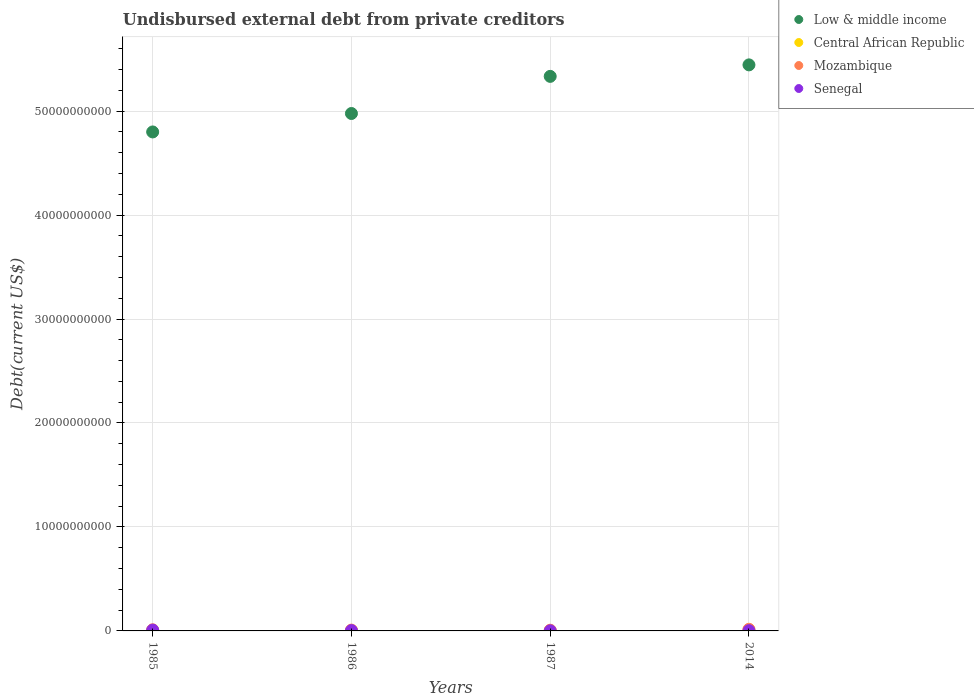What is the total debt in Central African Republic in 1985?
Your response must be concise. 2.37e+06. Across all years, what is the maximum total debt in Mozambique?
Offer a very short reply. 1.57e+08. Across all years, what is the minimum total debt in Senegal?
Offer a terse response. 1.13e+07. In which year was the total debt in Low & middle income maximum?
Offer a very short reply. 2014. What is the total total debt in Senegal in the graph?
Offer a very short reply. 1.46e+08. What is the difference between the total debt in Low & middle income in 1985 and that in 1986?
Offer a very short reply. -1.77e+09. What is the difference between the total debt in Senegal in 1986 and the total debt in Mozambique in 1987?
Give a very brief answer. -3.46e+07. What is the average total debt in Mozambique per year?
Your response must be concise. 1.04e+08. In the year 1987, what is the difference between the total debt in Low & middle income and total debt in Central African Republic?
Your answer should be compact. 5.33e+1. What is the ratio of the total debt in Central African Republic in 1986 to that in 2014?
Your response must be concise. 0.1. Is the difference between the total debt in Low & middle income in 1986 and 1987 greater than the difference between the total debt in Central African Republic in 1986 and 1987?
Your response must be concise. No. What is the difference between the highest and the second highest total debt in Central African Republic?
Provide a succinct answer. 1.76e+07. What is the difference between the highest and the lowest total debt in Mozambique?
Your answer should be very brief. 8.82e+07. In how many years, is the total debt in Low & middle income greater than the average total debt in Low & middle income taken over all years?
Ensure brevity in your answer.  2. Is the sum of the total debt in Low & middle income in 1985 and 1986 greater than the maximum total debt in Mozambique across all years?
Your answer should be compact. Yes. Is it the case that in every year, the sum of the total debt in Low & middle income and total debt in Senegal  is greater than the sum of total debt in Central African Republic and total debt in Mozambique?
Give a very brief answer. Yes. Does the total debt in Central African Republic monotonically increase over the years?
Your response must be concise. No. Is the total debt in Senegal strictly less than the total debt in Low & middle income over the years?
Make the answer very short. Yes. What is the difference between two consecutive major ticks on the Y-axis?
Offer a very short reply. 1.00e+1. Are the values on the major ticks of Y-axis written in scientific E-notation?
Your answer should be compact. No. Does the graph contain grids?
Provide a succinct answer. Yes. What is the title of the graph?
Offer a terse response. Undisbursed external debt from private creditors. What is the label or title of the X-axis?
Offer a terse response. Years. What is the label or title of the Y-axis?
Provide a short and direct response. Debt(current US$). What is the Debt(current US$) in Low & middle income in 1985?
Make the answer very short. 4.80e+1. What is the Debt(current US$) in Central African Republic in 1985?
Offer a very short reply. 2.37e+06. What is the Debt(current US$) in Mozambique in 1985?
Make the answer very short. 1.10e+08. What is the Debt(current US$) in Senegal in 1985?
Give a very brief answer. 7.67e+07. What is the Debt(current US$) of Low & middle income in 1986?
Your response must be concise. 4.98e+1. What is the Debt(current US$) in Central African Republic in 1986?
Keep it short and to the point. 1.96e+06. What is the Debt(current US$) in Mozambique in 1986?
Provide a succinct answer. 7.97e+07. What is the Debt(current US$) of Senegal in 1986?
Offer a very short reply. 3.37e+07. What is the Debt(current US$) in Low & middle income in 1987?
Your answer should be very brief. 5.33e+1. What is the Debt(current US$) of Central African Republic in 1987?
Your response must be concise. 1.33e+06. What is the Debt(current US$) of Mozambique in 1987?
Your answer should be very brief. 6.83e+07. What is the Debt(current US$) in Senegal in 1987?
Provide a short and direct response. 1.13e+07. What is the Debt(current US$) of Low & middle income in 2014?
Offer a terse response. 5.44e+1. What is the Debt(current US$) of Central African Republic in 2014?
Offer a terse response. 2.00e+07. What is the Debt(current US$) of Mozambique in 2014?
Keep it short and to the point. 1.57e+08. What is the Debt(current US$) in Senegal in 2014?
Offer a very short reply. 2.39e+07. Across all years, what is the maximum Debt(current US$) in Low & middle income?
Provide a succinct answer. 5.44e+1. Across all years, what is the maximum Debt(current US$) in Central African Republic?
Offer a terse response. 2.00e+07. Across all years, what is the maximum Debt(current US$) of Mozambique?
Give a very brief answer. 1.57e+08. Across all years, what is the maximum Debt(current US$) of Senegal?
Your answer should be compact. 7.67e+07. Across all years, what is the minimum Debt(current US$) of Low & middle income?
Give a very brief answer. 4.80e+1. Across all years, what is the minimum Debt(current US$) of Central African Republic?
Give a very brief answer. 1.33e+06. Across all years, what is the minimum Debt(current US$) of Mozambique?
Keep it short and to the point. 6.83e+07. Across all years, what is the minimum Debt(current US$) of Senegal?
Provide a succinct answer. 1.13e+07. What is the total Debt(current US$) of Low & middle income in the graph?
Provide a short and direct response. 2.06e+11. What is the total Debt(current US$) in Central African Republic in the graph?
Keep it short and to the point. 2.57e+07. What is the total Debt(current US$) in Mozambique in the graph?
Keep it short and to the point. 4.15e+08. What is the total Debt(current US$) of Senegal in the graph?
Your response must be concise. 1.46e+08. What is the difference between the Debt(current US$) in Low & middle income in 1985 and that in 1986?
Provide a short and direct response. -1.77e+09. What is the difference between the Debt(current US$) of Central African Republic in 1985 and that in 1986?
Offer a terse response. 4.17e+05. What is the difference between the Debt(current US$) in Mozambique in 1985 and that in 1986?
Provide a short and direct response. 3.05e+07. What is the difference between the Debt(current US$) in Senegal in 1985 and that in 1986?
Provide a short and direct response. 4.30e+07. What is the difference between the Debt(current US$) in Low & middle income in 1985 and that in 1987?
Offer a very short reply. -5.35e+09. What is the difference between the Debt(current US$) of Central African Republic in 1985 and that in 1987?
Your response must be concise. 1.04e+06. What is the difference between the Debt(current US$) in Mozambique in 1985 and that in 1987?
Provide a succinct answer. 4.18e+07. What is the difference between the Debt(current US$) of Senegal in 1985 and that in 1987?
Give a very brief answer. 6.54e+07. What is the difference between the Debt(current US$) in Low & middle income in 1985 and that in 2014?
Your answer should be compact. -6.45e+09. What is the difference between the Debt(current US$) in Central African Republic in 1985 and that in 2014?
Provide a succinct answer. -1.76e+07. What is the difference between the Debt(current US$) in Mozambique in 1985 and that in 2014?
Provide a short and direct response. -4.64e+07. What is the difference between the Debt(current US$) in Senegal in 1985 and that in 2014?
Make the answer very short. 5.28e+07. What is the difference between the Debt(current US$) in Low & middle income in 1986 and that in 1987?
Ensure brevity in your answer.  -3.57e+09. What is the difference between the Debt(current US$) of Central African Republic in 1986 and that in 1987?
Keep it short and to the point. 6.28e+05. What is the difference between the Debt(current US$) of Mozambique in 1986 and that in 1987?
Provide a succinct answer. 1.14e+07. What is the difference between the Debt(current US$) in Senegal in 1986 and that in 1987?
Offer a terse response. 2.24e+07. What is the difference between the Debt(current US$) of Low & middle income in 1986 and that in 2014?
Make the answer very short. -4.68e+09. What is the difference between the Debt(current US$) of Central African Republic in 1986 and that in 2014?
Offer a terse response. -1.80e+07. What is the difference between the Debt(current US$) in Mozambique in 1986 and that in 2014?
Your answer should be very brief. -7.69e+07. What is the difference between the Debt(current US$) of Senegal in 1986 and that in 2014?
Provide a short and direct response. 9.77e+06. What is the difference between the Debt(current US$) of Low & middle income in 1987 and that in 2014?
Provide a short and direct response. -1.11e+09. What is the difference between the Debt(current US$) in Central African Republic in 1987 and that in 2014?
Keep it short and to the point. -1.87e+07. What is the difference between the Debt(current US$) of Mozambique in 1987 and that in 2014?
Offer a very short reply. -8.82e+07. What is the difference between the Debt(current US$) of Senegal in 1987 and that in 2014?
Provide a short and direct response. -1.27e+07. What is the difference between the Debt(current US$) of Low & middle income in 1985 and the Debt(current US$) of Central African Republic in 1986?
Your response must be concise. 4.80e+1. What is the difference between the Debt(current US$) of Low & middle income in 1985 and the Debt(current US$) of Mozambique in 1986?
Your answer should be compact. 4.79e+1. What is the difference between the Debt(current US$) of Low & middle income in 1985 and the Debt(current US$) of Senegal in 1986?
Provide a succinct answer. 4.80e+1. What is the difference between the Debt(current US$) of Central African Republic in 1985 and the Debt(current US$) of Mozambique in 1986?
Offer a very short reply. -7.73e+07. What is the difference between the Debt(current US$) of Central African Republic in 1985 and the Debt(current US$) of Senegal in 1986?
Give a very brief answer. -3.13e+07. What is the difference between the Debt(current US$) in Mozambique in 1985 and the Debt(current US$) in Senegal in 1986?
Your answer should be very brief. 7.64e+07. What is the difference between the Debt(current US$) in Low & middle income in 1985 and the Debt(current US$) in Central African Republic in 1987?
Your answer should be very brief. 4.80e+1. What is the difference between the Debt(current US$) in Low & middle income in 1985 and the Debt(current US$) in Mozambique in 1987?
Your response must be concise. 4.79e+1. What is the difference between the Debt(current US$) in Low & middle income in 1985 and the Debt(current US$) in Senegal in 1987?
Offer a terse response. 4.80e+1. What is the difference between the Debt(current US$) of Central African Republic in 1985 and the Debt(current US$) of Mozambique in 1987?
Offer a very short reply. -6.59e+07. What is the difference between the Debt(current US$) of Central African Republic in 1985 and the Debt(current US$) of Senegal in 1987?
Offer a very short reply. -8.89e+06. What is the difference between the Debt(current US$) in Mozambique in 1985 and the Debt(current US$) in Senegal in 1987?
Provide a short and direct response. 9.89e+07. What is the difference between the Debt(current US$) of Low & middle income in 1985 and the Debt(current US$) of Central African Republic in 2014?
Offer a terse response. 4.80e+1. What is the difference between the Debt(current US$) of Low & middle income in 1985 and the Debt(current US$) of Mozambique in 2014?
Offer a terse response. 4.78e+1. What is the difference between the Debt(current US$) of Low & middle income in 1985 and the Debt(current US$) of Senegal in 2014?
Your answer should be very brief. 4.80e+1. What is the difference between the Debt(current US$) in Central African Republic in 1985 and the Debt(current US$) in Mozambique in 2014?
Keep it short and to the point. -1.54e+08. What is the difference between the Debt(current US$) in Central African Republic in 1985 and the Debt(current US$) in Senegal in 2014?
Your response must be concise. -2.15e+07. What is the difference between the Debt(current US$) in Mozambique in 1985 and the Debt(current US$) in Senegal in 2014?
Provide a short and direct response. 8.62e+07. What is the difference between the Debt(current US$) in Low & middle income in 1986 and the Debt(current US$) in Central African Republic in 1987?
Your answer should be very brief. 4.98e+1. What is the difference between the Debt(current US$) of Low & middle income in 1986 and the Debt(current US$) of Mozambique in 1987?
Your response must be concise. 4.97e+1. What is the difference between the Debt(current US$) of Low & middle income in 1986 and the Debt(current US$) of Senegal in 1987?
Provide a succinct answer. 4.98e+1. What is the difference between the Debt(current US$) in Central African Republic in 1986 and the Debt(current US$) in Mozambique in 1987?
Your answer should be compact. -6.63e+07. What is the difference between the Debt(current US$) in Central African Republic in 1986 and the Debt(current US$) in Senegal in 1987?
Offer a terse response. -9.31e+06. What is the difference between the Debt(current US$) in Mozambique in 1986 and the Debt(current US$) in Senegal in 1987?
Offer a very short reply. 6.84e+07. What is the difference between the Debt(current US$) of Low & middle income in 1986 and the Debt(current US$) of Central African Republic in 2014?
Your answer should be compact. 4.97e+1. What is the difference between the Debt(current US$) in Low & middle income in 1986 and the Debt(current US$) in Mozambique in 2014?
Your response must be concise. 4.96e+1. What is the difference between the Debt(current US$) in Low & middle income in 1986 and the Debt(current US$) in Senegal in 2014?
Keep it short and to the point. 4.97e+1. What is the difference between the Debt(current US$) in Central African Republic in 1986 and the Debt(current US$) in Mozambique in 2014?
Provide a short and direct response. -1.55e+08. What is the difference between the Debt(current US$) of Central African Republic in 1986 and the Debt(current US$) of Senegal in 2014?
Give a very brief answer. -2.20e+07. What is the difference between the Debt(current US$) in Mozambique in 1986 and the Debt(current US$) in Senegal in 2014?
Provide a short and direct response. 5.57e+07. What is the difference between the Debt(current US$) of Low & middle income in 1987 and the Debt(current US$) of Central African Republic in 2014?
Offer a very short reply. 5.33e+1. What is the difference between the Debt(current US$) in Low & middle income in 1987 and the Debt(current US$) in Mozambique in 2014?
Offer a terse response. 5.32e+1. What is the difference between the Debt(current US$) of Low & middle income in 1987 and the Debt(current US$) of Senegal in 2014?
Your answer should be compact. 5.33e+1. What is the difference between the Debt(current US$) in Central African Republic in 1987 and the Debt(current US$) in Mozambique in 2014?
Offer a terse response. -1.55e+08. What is the difference between the Debt(current US$) in Central African Republic in 1987 and the Debt(current US$) in Senegal in 2014?
Ensure brevity in your answer.  -2.26e+07. What is the difference between the Debt(current US$) in Mozambique in 1987 and the Debt(current US$) in Senegal in 2014?
Your response must be concise. 4.44e+07. What is the average Debt(current US$) in Low & middle income per year?
Make the answer very short. 5.14e+1. What is the average Debt(current US$) of Central African Republic per year?
Give a very brief answer. 6.41e+06. What is the average Debt(current US$) in Mozambique per year?
Your response must be concise. 1.04e+08. What is the average Debt(current US$) in Senegal per year?
Offer a very short reply. 3.64e+07. In the year 1985, what is the difference between the Debt(current US$) in Low & middle income and Debt(current US$) in Central African Republic?
Your answer should be very brief. 4.80e+1. In the year 1985, what is the difference between the Debt(current US$) in Low & middle income and Debt(current US$) in Mozambique?
Offer a terse response. 4.79e+1. In the year 1985, what is the difference between the Debt(current US$) of Low & middle income and Debt(current US$) of Senegal?
Provide a succinct answer. 4.79e+1. In the year 1985, what is the difference between the Debt(current US$) in Central African Republic and Debt(current US$) in Mozambique?
Give a very brief answer. -1.08e+08. In the year 1985, what is the difference between the Debt(current US$) of Central African Republic and Debt(current US$) of Senegal?
Ensure brevity in your answer.  -7.43e+07. In the year 1985, what is the difference between the Debt(current US$) of Mozambique and Debt(current US$) of Senegal?
Your answer should be compact. 3.34e+07. In the year 1986, what is the difference between the Debt(current US$) in Low & middle income and Debt(current US$) in Central African Republic?
Keep it short and to the point. 4.98e+1. In the year 1986, what is the difference between the Debt(current US$) in Low & middle income and Debt(current US$) in Mozambique?
Make the answer very short. 4.97e+1. In the year 1986, what is the difference between the Debt(current US$) in Low & middle income and Debt(current US$) in Senegal?
Offer a very short reply. 4.97e+1. In the year 1986, what is the difference between the Debt(current US$) in Central African Republic and Debt(current US$) in Mozambique?
Make the answer very short. -7.77e+07. In the year 1986, what is the difference between the Debt(current US$) in Central African Republic and Debt(current US$) in Senegal?
Your response must be concise. -3.17e+07. In the year 1986, what is the difference between the Debt(current US$) in Mozambique and Debt(current US$) in Senegal?
Your answer should be very brief. 4.60e+07. In the year 1987, what is the difference between the Debt(current US$) in Low & middle income and Debt(current US$) in Central African Republic?
Your answer should be compact. 5.33e+1. In the year 1987, what is the difference between the Debt(current US$) in Low & middle income and Debt(current US$) in Mozambique?
Ensure brevity in your answer.  5.33e+1. In the year 1987, what is the difference between the Debt(current US$) of Low & middle income and Debt(current US$) of Senegal?
Your answer should be very brief. 5.33e+1. In the year 1987, what is the difference between the Debt(current US$) in Central African Republic and Debt(current US$) in Mozambique?
Give a very brief answer. -6.70e+07. In the year 1987, what is the difference between the Debt(current US$) in Central African Republic and Debt(current US$) in Senegal?
Keep it short and to the point. -9.94e+06. In the year 1987, what is the difference between the Debt(current US$) of Mozambique and Debt(current US$) of Senegal?
Offer a very short reply. 5.70e+07. In the year 2014, what is the difference between the Debt(current US$) of Low & middle income and Debt(current US$) of Central African Republic?
Offer a terse response. 5.44e+1. In the year 2014, what is the difference between the Debt(current US$) of Low & middle income and Debt(current US$) of Mozambique?
Ensure brevity in your answer.  5.43e+1. In the year 2014, what is the difference between the Debt(current US$) of Low & middle income and Debt(current US$) of Senegal?
Give a very brief answer. 5.44e+1. In the year 2014, what is the difference between the Debt(current US$) in Central African Republic and Debt(current US$) in Mozambique?
Your response must be concise. -1.37e+08. In the year 2014, what is the difference between the Debt(current US$) in Central African Republic and Debt(current US$) in Senegal?
Ensure brevity in your answer.  -3.92e+06. In the year 2014, what is the difference between the Debt(current US$) in Mozambique and Debt(current US$) in Senegal?
Provide a succinct answer. 1.33e+08. What is the ratio of the Debt(current US$) of Low & middle income in 1985 to that in 1986?
Make the answer very short. 0.96. What is the ratio of the Debt(current US$) in Central African Republic in 1985 to that in 1986?
Provide a succinct answer. 1.21. What is the ratio of the Debt(current US$) in Mozambique in 1985 to that in 1986?
Your answer should be compact. 1.38. What is the ratio of the Debt(current US$) of Senegal in 1985 to that in 1986?
Your answer should be compact. 2.28. What is the ratio of the Debt(current US$) in Low & middle income in 1985 to that in 1987?
Offer a very short reply. 0.9. What is the ratio of the Debt(current US$) in Central African Republic in 1985 to that in 1987?
Offer a very short reply. 1.79. What is the ratio of the Debt(current US$) of Mozambique in 1985 to that in 1987?
Provide a succinct answer. 1.61. What is the ratio of the Debt(current US$) of Senegal in 1985 to that in 1987?
Offer a terse response. 6.81. What is the ratio of the Debt(current US$) of Low & middle income in 1985 to that in 2014?
Your answer should be very brief. 0.88. What is the ratio of the Debt(current US$) of Central African Republic in 1985 to that in 2014?
Offer a very short reply. 0.12. What is the ratio of the Debt(current US$) of Mozambique in 1985 to that in 2014?
Make the answer very short. 0.7. What is the ratio of the Debt(current US$) in Senegal in 1985 to that in 2014?
Your answer should be compact. 3.21. What is the ratio of the Debt(current US$) of Low & middle income in 1986 to that in 1987?
Your response must be concise. 0.93. What is the ratio of the Debt(current US$) in Central African Republic in 1986 to that in 1987?
Give a very brief answer. 1.47. What is the ratio of the Debt(current US$) of Mozambique in 1986 to that in 1987?
Offer a very short reply. 1.17. What is the ratio of the Debt(current US$) in Senegal in 1986 to that in 1987?
Offer a terse response. 2.99. What is the ratio of the Debt(current US$) in Low & middle income in 1986 to that in 2014?
Your answer should be very brief. 0.91. What is the ratio of the Debt(current US$) of Central African Republic in 1986 to that in 2014?
Provide a short and direct response. 0.1. What is the ratio of the Debt(current US$) of Mozambique in 1986 to that in 2014?
Provide a short and direct response. 0.51. What is the ratio of the Debt(current US$) in Senegal in 1986 to that in 2014?
Give a very brief answer. 1.41. What is the ratio of the Debt(current US$) in Low & middle income in 1987 to that in 2014?
Offer a terse response. 0.98. What is the ratio of the Debt(current US$) of Central African Republic in 1987 to that in 2014?
Make the answer very short. 0.07. What is the ratio of the Debt(current US$) of Mozambique in 1987 to that in 2014?
Keep it short and to the point. 0.44. What is the ratio of the Debt(current US$) in Senegal in 1987 to that in 2014?
Give a very brief answer. 0.47. What is the difference between the highest and the second highest Debt(current US$) in Low & middle income?
Offer a terse response. 1.11e+09. What is the difference between the highest and the second highest Debt(current US$) in Central African Republic?
Ensure brevity in your answer.  1.76e+07. What is the difference between the highest and the second highest Debt(current US$) in Mozambique?
Make the answer very short. 4.64e+07. What is the difference between the highest and the second highest Debt(current US$) in Senegal?
Offer a very short reply. 4.30e+07. What is the difference between the highest and the lowest Debt(current US$) in Low & middle income?
Your response must be concise. 6.45e+09. What is the difference between the highest and the lowest Debt(current US$) of Central African Republic?
Offer a very short reply. 1.87e+07. What is the difference between the highest and the lowest Debt(current US$) of Mozambique?
Your response must be concise. 8.82e+07. What is the difference between the highest and the lowest Debt(current US$) of Senegal?
Offer a very short reply. 6.54e+07. 